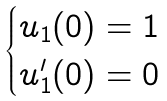Convert formula to latex. <formula><loc_0><loc_0><loc_500><loc_500>\begin{cases} u _ { 1 } ( 0 ) = 1 & \\ u _ { 1 } ^ { \prime } ( 0 ) = 0 & \end{cases}</formula> 